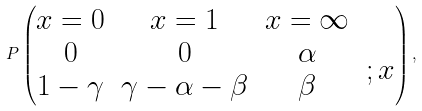<formula> <loc_0><loc_0><loc_500><loc_500>P \left ( \begin{matrix} x = 0 & x = 1 & x = \infty & \\ \begin{matrix} 0 \\ 1 - \gamma \end{matrix} & \begin{matrix} 0 \\ \gamma - \alpha - \beta \end{matrix} & \begin{matrix} \alpha \\ \beta \end{matrix} & \begin{matrix} ; x \\ \end{matrix} \end{matrix} \right ) ,</formula> 